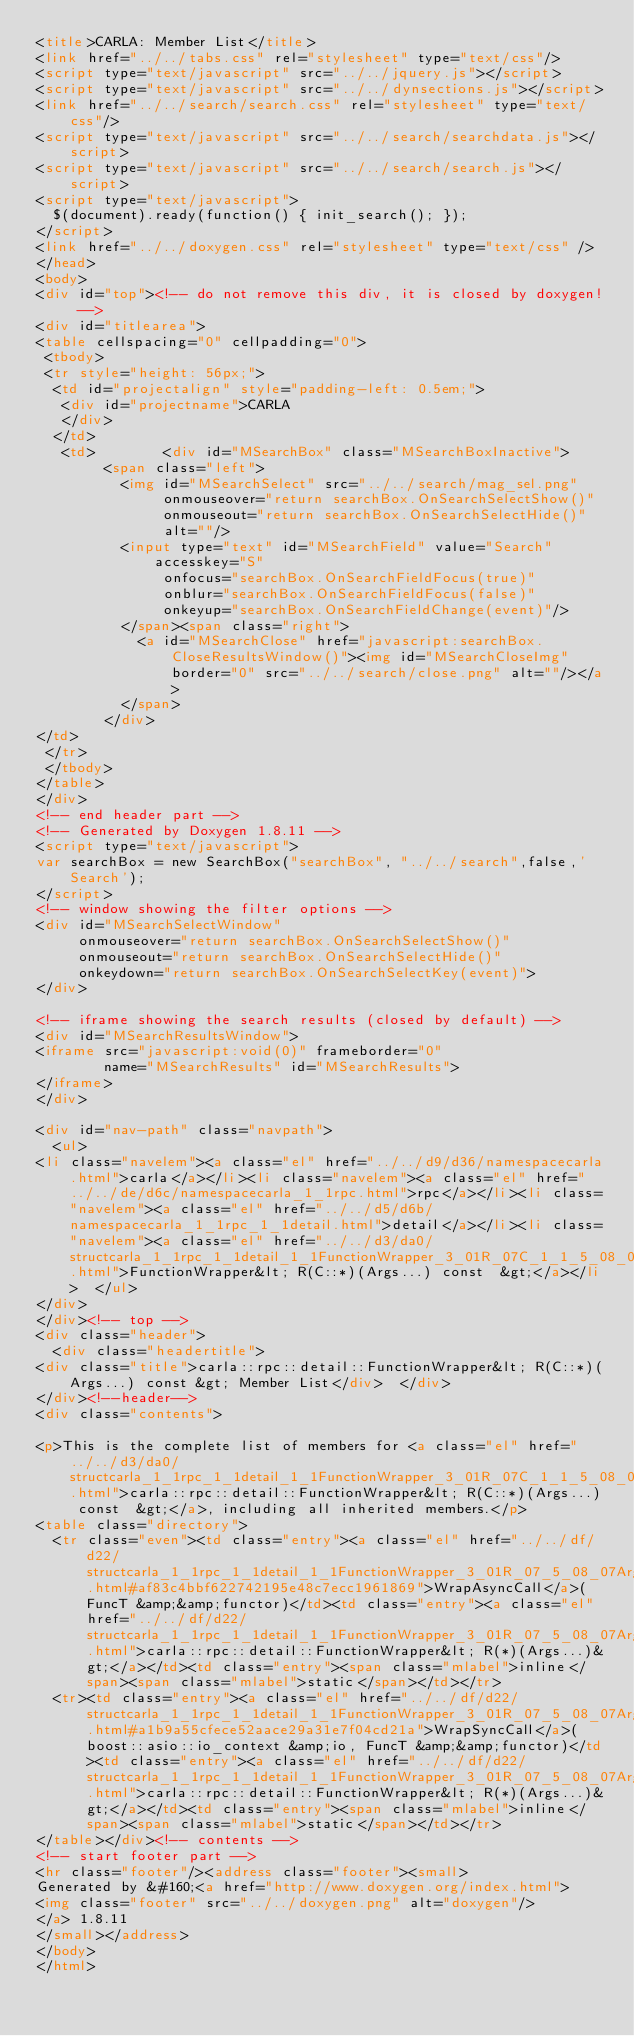<code> <loc_0><loc_0><loc_500><loc_500><_HTML_><title>CARLA: Member List</title>
<link href="../../tabs.css" rel="stylesheet" type="text/css"/>
<script type="text/javascript" src="../../jquery.js"></script>
<script type="text/javascript" src="../../dynsections.js"></script>
<link href="../../search/search.css" rel="stylesheet" type="text/css"/>
<script type="text/javascript" src="../../search/searchdata.js"></script>
<script type="text/javascript" src="../../search/search.js"></script>
<script type="text/javascript">
  $(document).ready(function() { init_search(); });
</script>
<link href="../../doxygen.css" rel="stylesheet" type="text/css" />
</head>
<body>
<div id="top"><!-- do not remove this div, it is closed by doxygen! -->
<div id="titlearea">
<table cellspacing="0" cellpadding="0">
 <tbody>
 <tr style="height: 56px;">
  <td id="projectalign" style="padding-left: 0.5em;">
   <div id="projectname">CARLA
   </div>
  </td>
   <td>        <div id="MSearchBox" class="MSearchBoxInactive">
        <span class="left">
          <img id="MSearchSelect" src="../../search/mag_sel.png"
               onmouseover="return searchBox.OnSearchSelectShow()"
               onmouseout="return searchBox.OnSearchSelectHide()"
               alt=""/>
          <input type="text" id="MSearchField" value="Search" accesskey="S"
               onfocus="searchBox.OnSearchFieldFocus(true)" 
               onblur="searchBox.OnSearchFieldFocus(false)" 
               onkeyup="searchBox.OnSearchFieldChange(event)"/>
          </span><span class="right">
            <a id="MSearchClose" href="javascript:searchBox.CloseResultsWindow()"><img id="MSearchCloseImg" border="0" src="../../search/close.png" alt=""/></a>
          </span>
        </div>
</td>
 </tr>
 </tbody>
</table>
</div>
<!-- end header part -->
<!-- Generated by Doxygen 1.8.11 -->
<script type="text/javascript">
var searchBox = new SearchBox("searchBox", "../../search",false,'Search');
</script>
<!-- window showing the filter options -->
<div id="MSearchSelectWindow"
     onmouseover="return searchBox.OnSearchSelectShow()"
     onmouseout="return searchBox.OnSearchSelectHide()"
     onkeydown="return searchBox.OnSearchSelectKey(event)">
</div>

<!-- iframe showing the search results (closed by default) -->
<div id="MSearchResultsWindow">
<iframe src="javascript:void(0)" frameborder="0" 
        name="MSearchResults" id="MSearchResults">
</iframe>
</div>

<div id="nav-path" class="navpath">
  <ul>
<li class="navelem"><a class="el" href="../../d9/d36/namespacecarla.html">carla</a></li><li class="navelem"><a class="el" href="../../de/d6c/namespacecarla_1_1rpc.html">rpc</a></li><li class="navelem"><a class="el" href="../../d5/d6b/namespacecarla_1_1rpc_1_1detail.html">detail</a></li><li class="navelem"><a class="el" href="../../d3/da0/structcarla_1_1rpc_1_1detail_1_1FunctionWrapper_3_01R_07C_1_1_5_08_07Args_8_8_8_08_01const_01_01_4.html">FunctionWrapper&lt; R(C::*)(Args...) const  &gt;</a></li>  </ul>
</div>
</div><!-- top -->
<div class="header">
  <div class="headertitle">
<div class="title">carla::rpc::detail::FunctionWrapper&lt; R(C::*)(Args...) const &gt; Member List</div>  </div>
</div><!--header-->
<div class="contents">

<p>This is the complete list of members for <a class="el" href="../../d3/da0/structcarla_1_1rpc_1_1detail_1_1FunctionWrapper_3_01R_07C_1_1_5_08_07Args_8_8_8_08_01const_01_01_4.html">carla::rpc::detail::FunctionWrapper&lt; R(C::*)(Args...) const  &gt;</a>, including all inherited members.</p>
<table class="directory">
  <tr class="even"><td class="entry"><a class="el" href="../../df/d22/structcarla_1_1rpc_1_1detail_1_1FunctionWrapper_3_01R_07_5_08_07Args_8_8_8_08_4.html#af83c4bbf622742195e48c7ecc1961869">WrapAsyncCall</a>(FuncT &amp;&amp;functor)</td><td class="entry"><a class="el" href="../../df/d22/structcarla_1_1rpc_1_1detail_1_1FunctionWrapper_3_01R_07_5_08_07Args_8_8_8_08_4.html">carla::rpc::detail::FunctionWrapper&lt; R(*)(Args...)&gt;</a></td><td class="entry"><span class="mlabel">inline</span><span class="mlabel">static</span></td></tr>
  <tr><td class="entry"><a class="el" href="../../df/d22/structcarla_1_1rpc_1_1detail_1_1FunctionWrapper_3_01R_07_5_08_07Args_8_8_8_08_4.html#a1b9a55cfece52aace29a31e7f04cd21a">WrapSyncCall</a>(boost::asio::io_context &amp;io, FuncT &amp;&amp;functor)</td><td class="entry"><a class="el" href="../../df/d22/structcarla_1_1rpc_1_1detail_1_1FunctionWrapper_3_01R_07_5_08_07Args_8_8_8_08_4.html">carla::rpc::detail::FunctionWrapper&lt; R(*)(Args...)&gt;</a></td><td class="entry"><span class="mlabel">inline</span><span class="mlabel">static</span></td></tr>
</table></div><!-- contents -->
<!-- start footer part -->
<hr class="footer"/><address class="footer"><small>
Generated by &#160;<a href="http://www.doxygen.org/index.html">
<img class="footer" src="../../doxygen.png" alt="doxygen"/>
</a> 1.8.11
</small></address>
</body>
</html>
</code> 